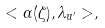<formula> <loc_0><loc_0><loc_500><loc_500>< \alpha ( \zeta ) , \lambda _ { u ^ { \prime } } > ,</formula> 